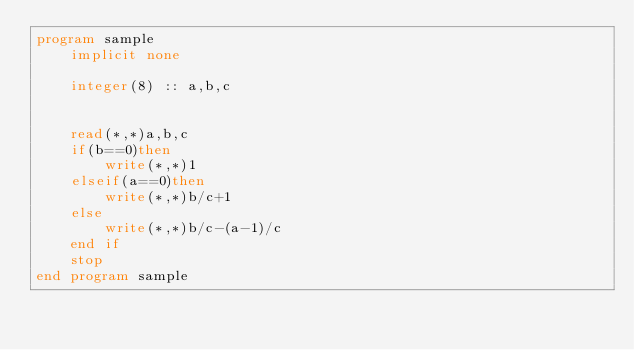<code> <loc_0><loc_0><loc_500><loc_500><_FORTRAN_>program sample
    implicit none
   
    integer(8) :: a,b,c
    
  
    read(*,*)a,b,c
    if(b==0)then
        write(*,*)1
    elseif(a==0)then
        write(*,*)b/c+1
    else
        write(*,*)b/c-(a-1)/c
    end if
    stop
end program sample
  

</code> 